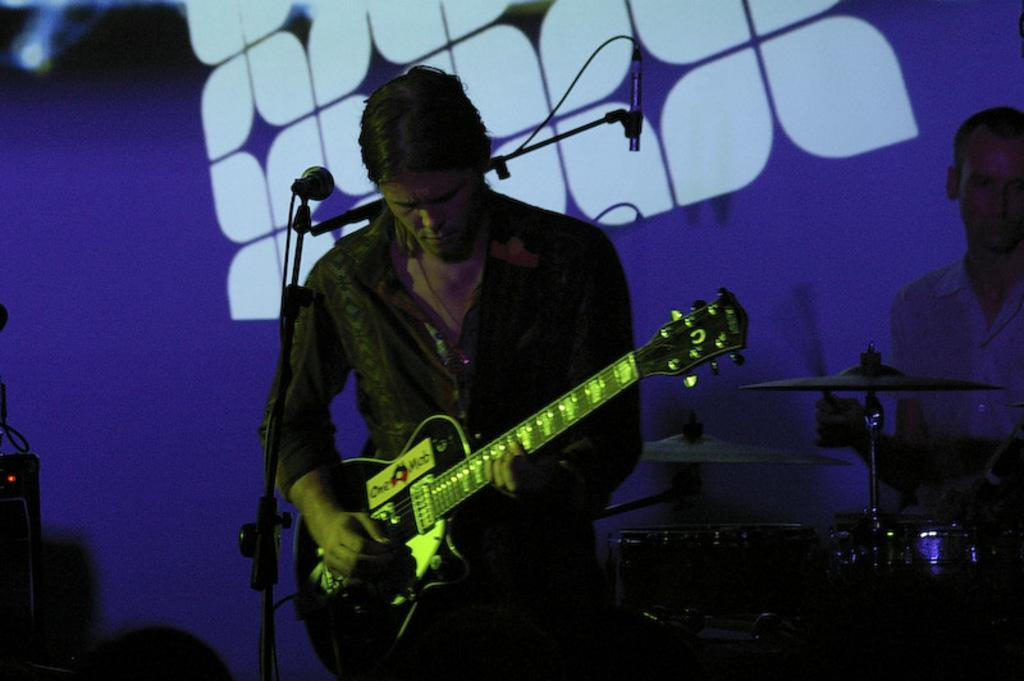What is the man in the image doing? The man is playing the guitar in the image. What object is behind the man? There is a microphone behind the man. Are there any other people in the image? Yes, another man is present in the image. What is the second man doing? The second man is playing musical instruments. How many legs does the jelly have in the image? There is no jelly present in the image, so it is not possible to determine the number of legs it might have. 